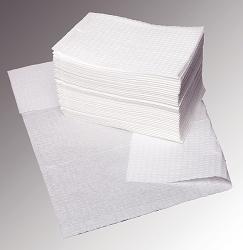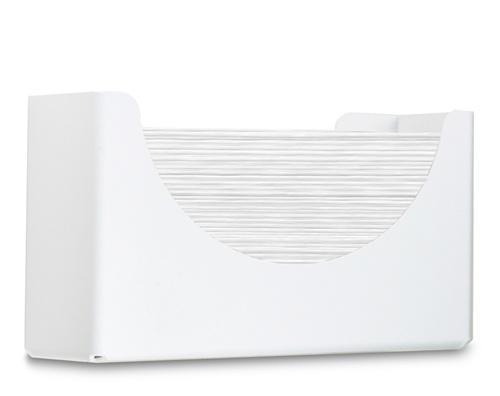The first image is the image on the left, the second image is the image on the right. For the images displayed, is the sentence "The right image shows an opaque gray wall-mount dispenser with a white paper towel hanging below it." factually correct? Answer yes or no. No. The first image is the image on the left, the second image is the image on the right. Evaluate the accuracy of this statement regarding the images: "White paper is coming out of a grey dispenser in the image on the right.". Is it true? Answer yes or no. No. 